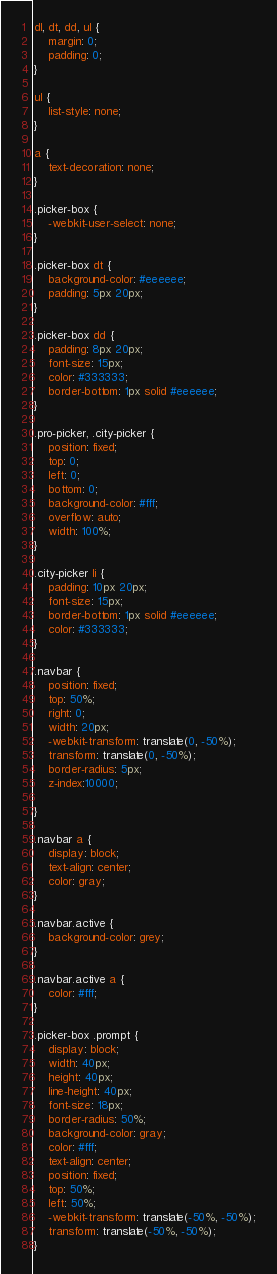<code> <loc_0><loc_0><loc_500><loc_500><_CSS_>dl, dt, dd, ul {
    margin: 0;
    padding: 0;
}

ul {
    list-style: none;
}

a {
    text-decoration: none;
}

.picker-box {
    -webkit-user-select: none;
}

.picker-box dt {
    background-color: #eeeeee;
    padding: 5px 20px;
}

.picker-box dd {
    padding: 8px 20px;
    font-size: 15px;
    color: #333333;
    border-bottom: 1px solid #eeeeee;
}

.pro-picker, .city-picker {
    position: fixed;
    top: 0;
    left: 0;
    bottom: 0;
    background-color: #fff;
    overflow: auto;
    width: 100%;
}

.city-picker li {
    padding: 10px 20px;
    font-size: 15px;
    border-bottom: 1px solid #eeeeee;
    color: #333333;
}

.navbar {
    position: fixed;
    top: 50%;
    right: 0;
    width: 20px;
    -webkit-transform: translate(0, -50%);
    transform: translate(0, -50%);
    border-radius: 5px;
    z-index:10000;

}

.navbar a {
    display: block;
    text-align: center;
    color: gray;
}

.navbar.active {
    background-color: grey;
}

.navbar.active a {
    color: #fff;
}

.picker-box .prompt {
    display: block;
    width: 40px;
    height: 40px;
    line-height: 40px;
    font-size: 18px;
    border-radius: 50%;
    background-color: gray;
    color: #fff;
    text-align: center;
    position: fixed;
    top: 50%;
    left: 50%;
    -webkit-transform: translate(-50%, -50%);
    transform: translate(-50%, -50%);
}</code> 